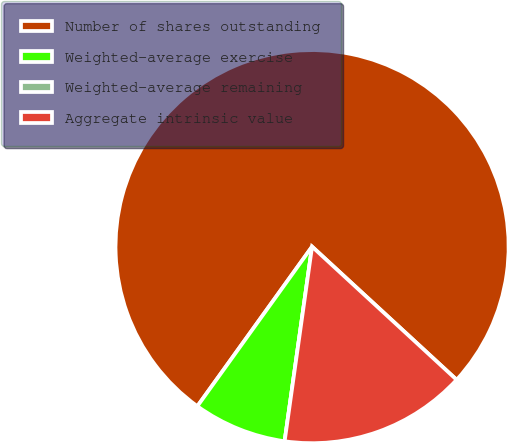<chart> <loc_0><loc_0><loc_500><loc_500><pie_chart><fcel>Number of shares outstanding<fcel>Weighted-average exercise<fcel>Weighted-average remaining<fcel>Aggregate intrinsic value<nl><fcel>76.92%<fcel>7.69%<fcel>0.0%<fcel>15.38%<nl></chart> 